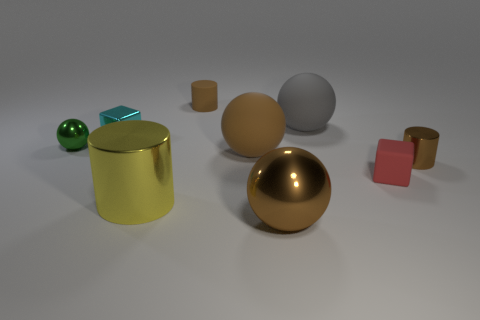Subtract 1 spheres. How many spheres are left? 3 Subtract all brown cubes. Subtract all red balls. How many cubes are left? 2 Subtract all balls. How many objects are left? 5 Subtract 1 yellow cylinders. How many objects are left? 8 Subtract all small cyan shiny things. Subtract all large gray things. How many objects are left? 7 Add 3 brown rubber balls. How many brown rubber balls are left? 4 Add 5 green objects. How many green objects exist? 6 